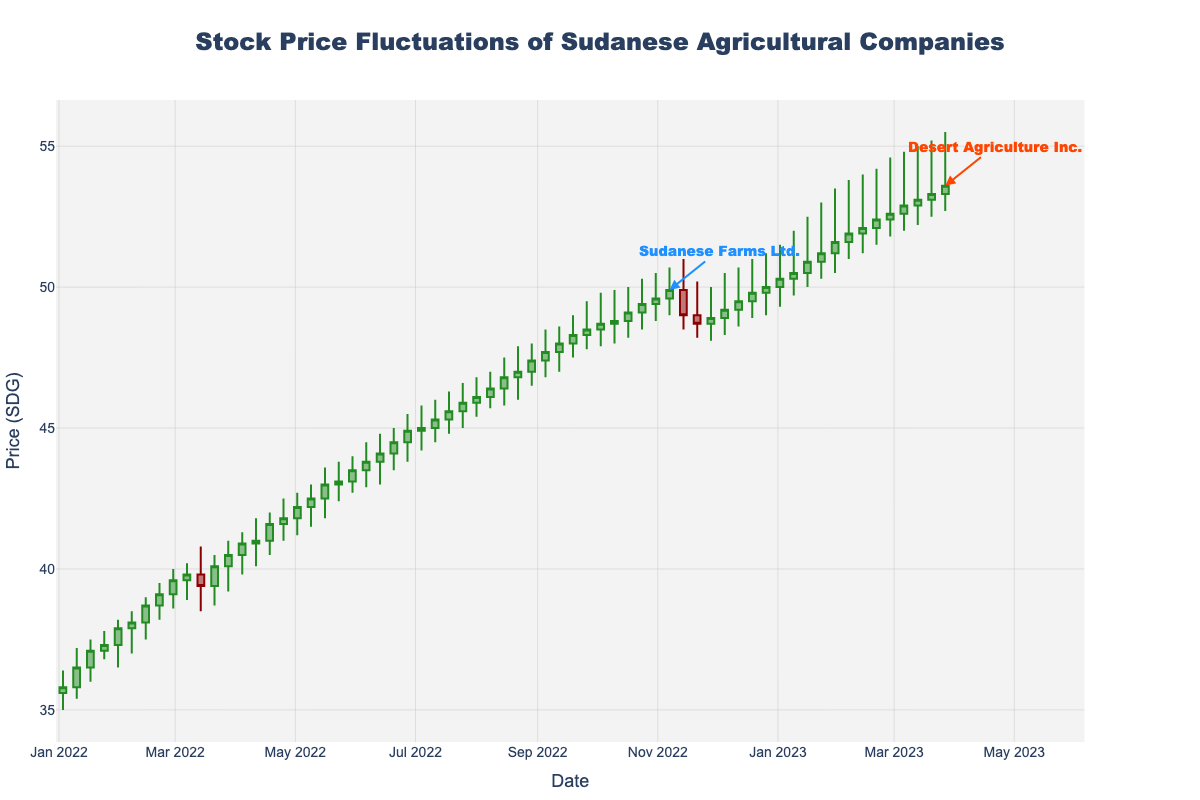What is the title of the figure? The title of the figure is displayed prominently at the top.
Answer: Stock Price Fluctuations of Sudanese Agricultural Companies What does the x-axis represent in the figure? The x-axis is labeled "Date," indicating the dates over which the data was collected.
Answer: Date Which company had the highest closing price at the end of the year? The end of the year point is December 26, 2022, where the data shows that Desert Agriculture Inc. had the highest closing price among the companies.
Answer: Desert Agriculture Inc Did Sudanese Farms Ltd. experience an increase or decrease in stock price from February 21, 2022, to February 28, 2022? By looking at the closing prices on February 21 (39.1) and February 28 (39.6), we notice an increase.
Answer: Increase Which company had a larger range of stock prices from the highest high to the lowest low during the year? Compare the highest high and the lowest low points for both companies to see which range is larger. Sudanese Farms Ltd. has a range from 36.5 to 49.9 (13.4), while Desert Agriculture Inc. ranges from 48.1 to 55.5 (7.4).
Answer: Sudanese Farms Ltd Between November 7, 2022, and November 14, 2022, what change occurred in the company being tracked? The annotations indicate that on November 14, 2022, the company changed from Sudanese Farms Ltd. to Desert Agriculture Inc.
Answer: The company changed from Sudanese Farms Ltd. to Desert Agriculture Inc What was the closing price trend for Sudanese Farms Ltd. from January to June 2022? The trend can be determined by looking at the closing prices at the beginning and end of this period. The prices increased from 35.8 in January to around 44.9 in June.
Answer: Increasing What is the maximum closing price achieved by Desert Agriculture Inc., and when did it occur? Check the candlesticks for Desert Agriculture Inc. for the highest closing price and its corresponding date. The maximum closing price is 53.6 on March 27, 2023.
Answer: 53.6 on March 27, 2023 What was the average closing price for Sudanese Farms Ltd. in July 2022? Calculate the average of the closing prices for each week in July 2022. (45.0 + 45.3 + 45.6 + 45.9) / 4 = (181.8) / 4 = 45.45
Answer: 45.45 